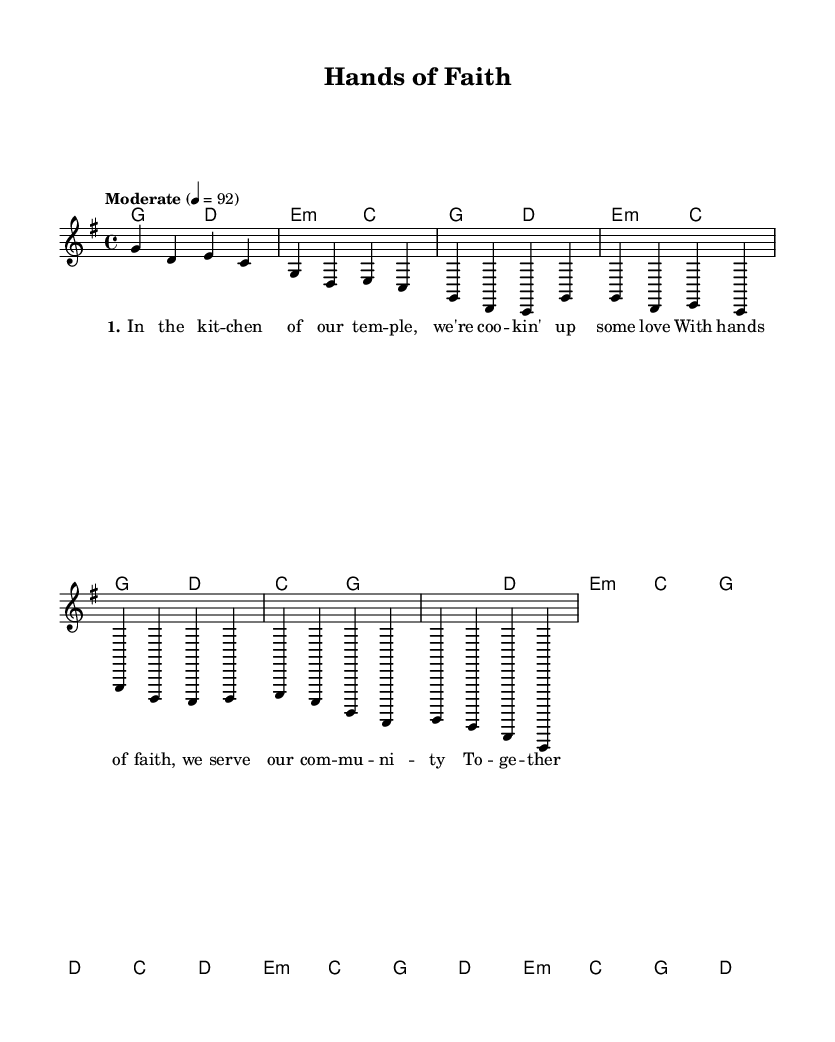What is the key signature of this music? The key signature is indicated at the beginning of the piece. It has one sharp (F#) in G major.
Answer: G major What is the time signature of this music? The time signature is written at the beginning of the piece, showing that there are four beats in a measure.
Answer: 4/4 What is the tempo marking for this music? The tempo marking is written above the staff, specifying a moderate speed of the piece, which translates to 92 beats per minute.
Answer: Moderate 4 = 92 How many measures are in the introduction? The introduction consists of two measures as indicated by the number of bars notated in that section of the score.
Answer: 2 How many verses does the song have? The song includes a single verse section before the chorus, making it possible to identify this from the structure outlined in the score.
Answer: 1 What musical genre is represented by this piece? The song's title, lyrics, and style reflect characteristics commonly associated with a specific genre identified with themes of faith and community service, typical in country music.
Answer: Country What is the main theme of the lyrics in this song? The lyrics talk about kitchen activities in a temple and highlight community service, which is indicative of the song's focus on faith and togetherness.
Answer: Service 